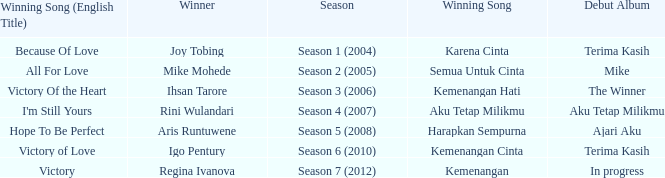Which winning song had a debut album in progress? Kemenangan. 